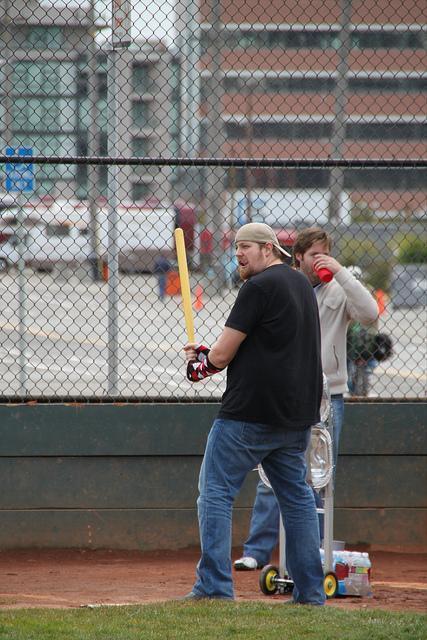How many people are there?
Give a very brief answer. 2. 